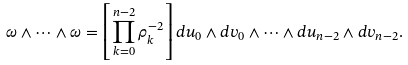Convert formula to latex. <formula><loc_0><loc_0><loc_500><loc_500>\omega \wedge \cdots \wedge \omega = \left [ \prod _ { k = 0 } ^ { n - 2 } \rho _ { k } ^ { - 2 } \right ] d u _ { 0 } \wedge d v _ { 0 } \wedge \cdots \wedge d u _ { n - 2 } \wedge d v _ { n - 2 } .</formula> 